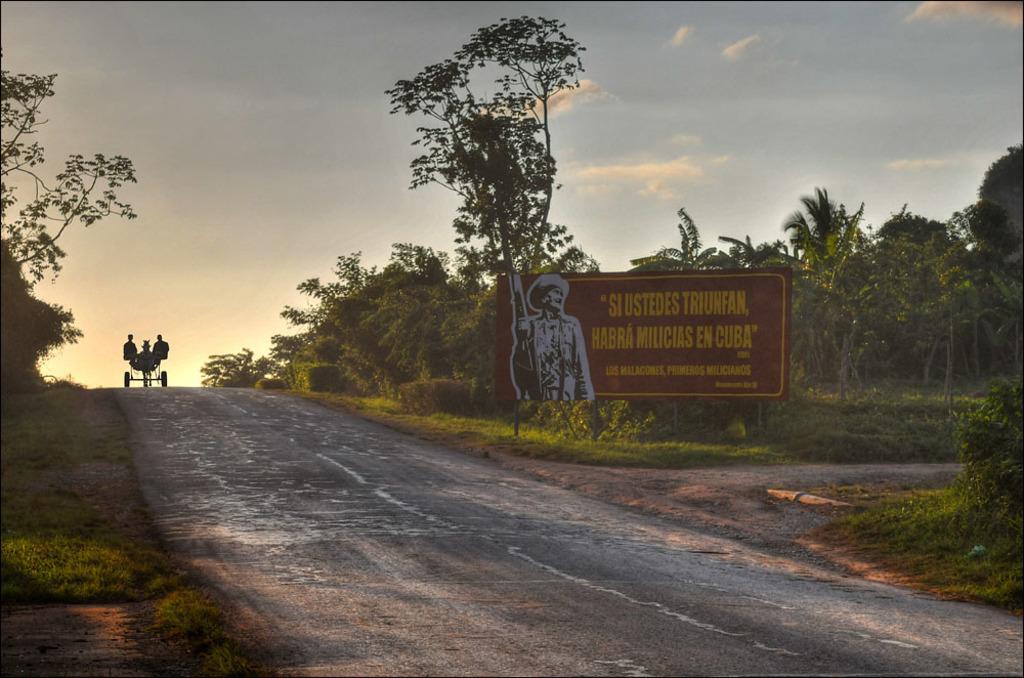Can you describe this image briefly? In this picture we can see red color board on which there is a person's painting. On the left we can see two persons sitting on the chariot. On the top we can see sky and clouds. On the right we can see trees, plants and grass. On the bottom there is a road here we can see a horse. 